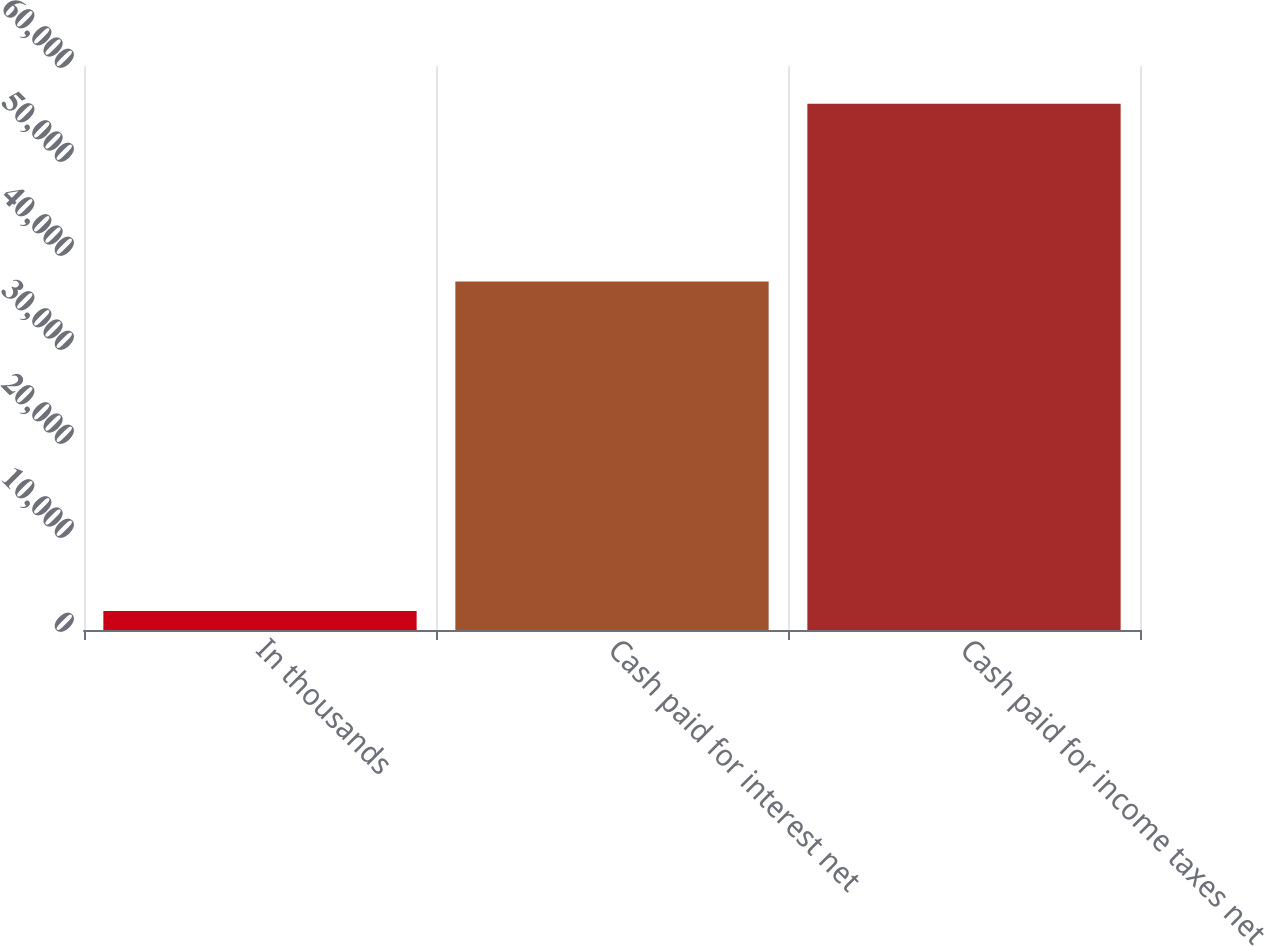Convert chart to OTSL. <chart><loc_0><loc_0><loc_500><loc_500><bar_chart><fcel>In thousands<fcel>Cash paid for interest net<fcel>Cash paid for income taxes net<nl><fcel>2010<fcel>37083<fcel>55991<nl></chart> 